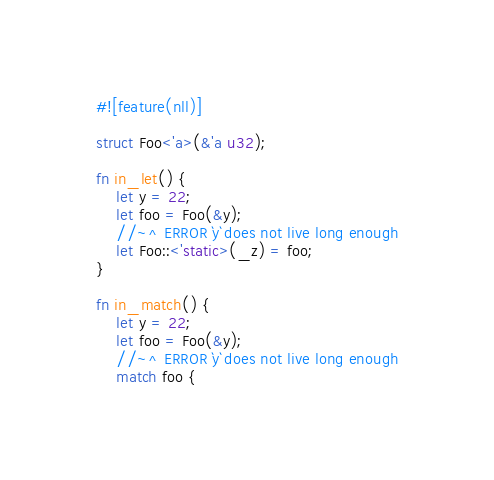Convert code to text. <code><loc_0><loc_0><loc_500><loc_500><_Rust_>#![feature(nll)]

struct Foo<'a>(&'a u32);

fn in_let() {
    let y = 22;
    let foo = Foo(&y);
    //~^ ERROR `y` does not live long enough
    let Foo::<'static>(_z) = foo;
}

fn in_match() {
    let y = 22;
    let foo = Foo(&y);
    //~^ ERROR `y` does not live long enough
    match foo {</code> 